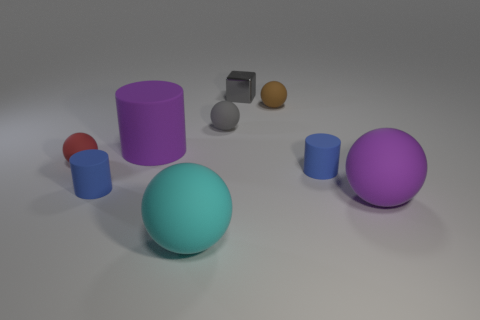How many cylinders are big purple matte things or large cyan things?
Provide a short and direct response. 1. The shiny thing is what color?
Ensure brevity in your answer.  Gray. Is the number of cyan rubber balls greater than the number of big yellow metallic spheres?
Provide a short and direct response. Yes. What number of objects are red matte spheres in front of the small brown matte object or tiny shiny blocks?
Offer a terse response. 2. Are the tiny red object and the large cylinder made of the same material?
Offer a very short reply. Yes. There is a purple matte thing that is the same shape as the large cyan matte object; what size is it?
Provide a short and direct response. Large. Do the tiny blue object left of the tiny gray rubber thing and the purple rubber thing on the left side of the small brown matte thing have the same shape?
Your response must be concise. Yes. There is a gray metal cube; does it have the same size as the purple thing that is in front of the purple matte cylinder?
Keep it short and to the point. No. How many other objects are the same material as the purple sphere?
Offer a very short reply. 7. Is there any other thing that is the same shape as the tiny gray metallic thing?
Ensure brevity in your answer.  No. 